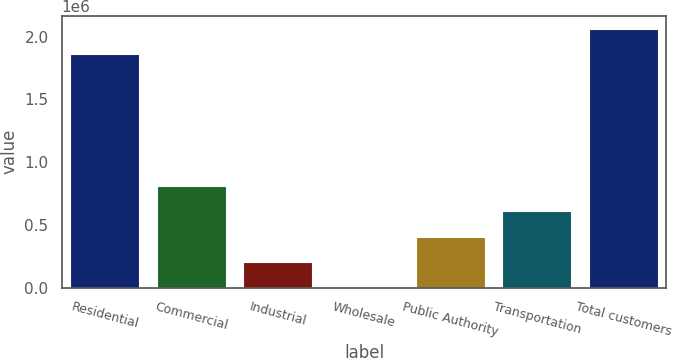Convert chart. <chart><loc_0><loc_0><loc_500><loc_500><bar_chart><fcel>Residential<fcel>Commercial<fcel>Industrial<fcel>Wholesale<fcel>Public Authority<fcel>Transportation<fcel>Total customers<nl><fcel>1.85948e+06<fcel>812631<fcel>203171<fcel>18<fcel>406325<fcel>609478<fcel>2.06263e+06<nl></chart> 